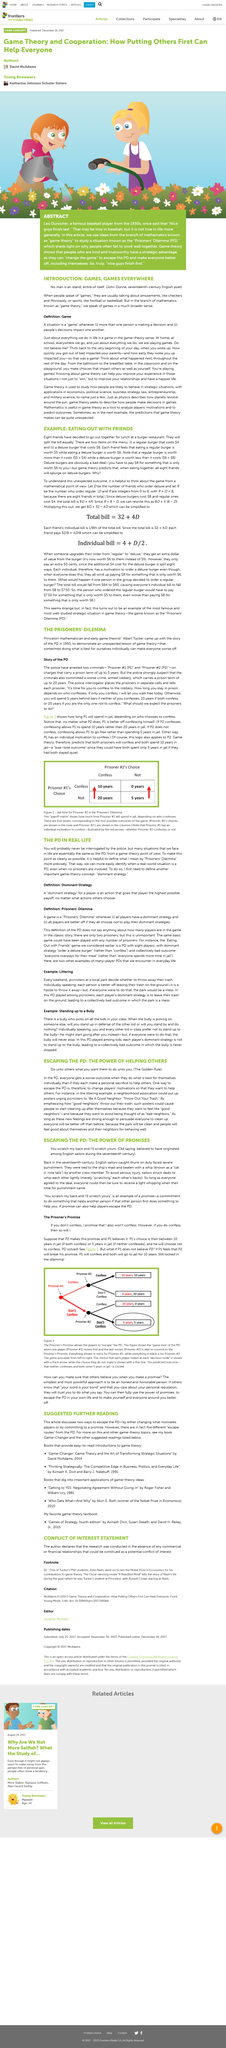Outline some significant characteristics in this image. The saying, originating among English sailors, is "You scratch my back and I'll scratch yours." This message conveys an agreement to reciprocate a favor granted to another person. Yes, PD can be found in real life. I am aware that PD stands for 'Prisoners Dilemma,' a scenario in which two individuals are faced with a difficult decision, often leading to an unfulfilling outcome for both parties. The article is about English sailors. In this article, PD is an abbreviation for the concept of the Prisoners' Dilemma. 